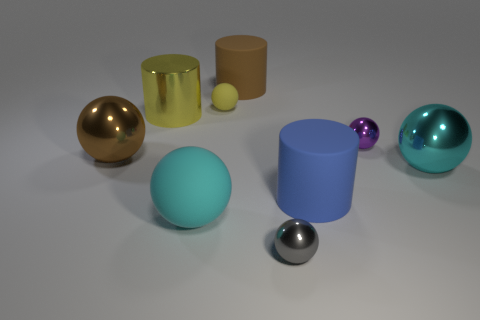Subtract all large cyan rubber spheres. How many spheres are left? 5 Subtract all brown spheres. How many spheres are left? 5 Add 1 tiny yellow rubber objects. How many objects exist? 10 Subtract all cylinders. How many objects are left? 6 Subtract all green spheres. Subtract all brown cylinders. How many spheres are left? 6 Subtract all large blue rubber cylinders. Subtract all blue rubber cylinders. How many objects are left? 7 Add 6 big cyan matte objects. How many big cyan matte objects are left? 7 Add 2 big blue metal cylinders. How many big blue metal cylinders exist? 2 Subtract 0 brown cubes. How many objects are left? 9 